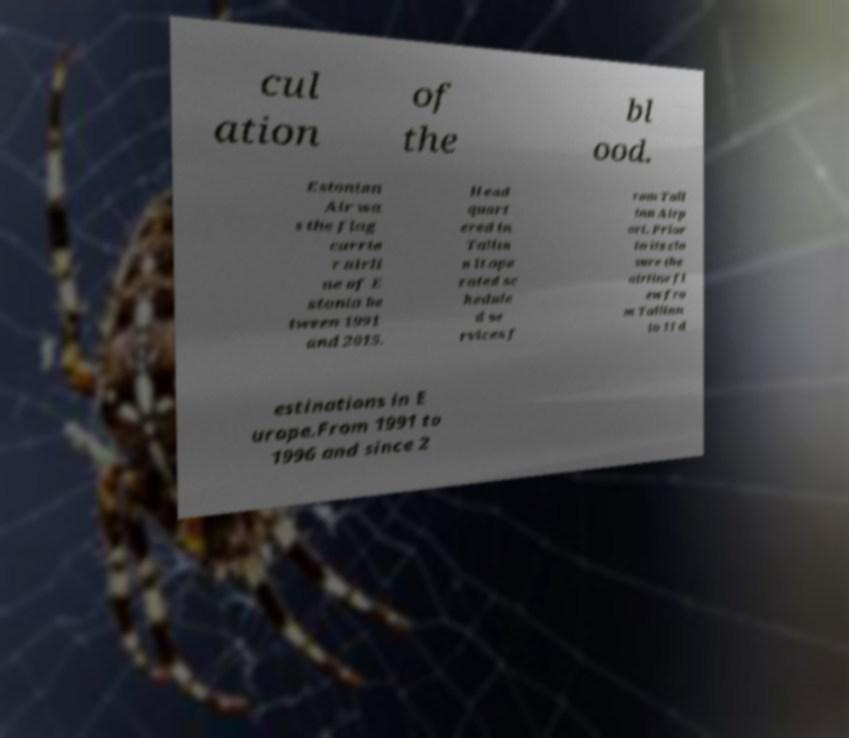Could you extract and type out the text from this image? cul ation of the bl ood. Estonian Air wa s the flag carrie r airli ne of E stonia be tween 1991 and 2015. Head quart ered in Tallin n it ope rated sc hedule d se rvices f rom Tall inn Airp ort. Prior to its clo sure the airline fl ew fro m Tallinn to 11 d estinations in E urope.From 1991 to 1996 and since 2 